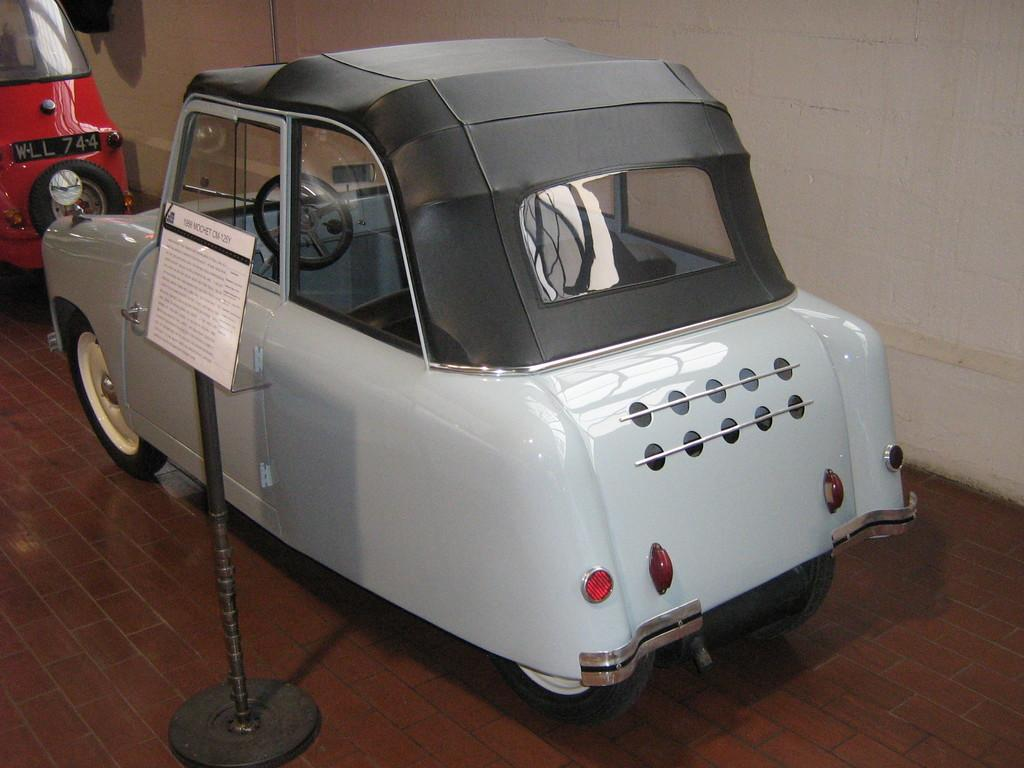What types of objects are present in the image? There are vehicles, a text board with a stand, a wall, and a floor in the image. Can you describe the vehicles in the image? The facts provided do not specify the type of vehicles in the image. What is the text board with a stand used for? The purpose of the text board with a stand is not mentioned in the facts. What is the wall made of? The facts provided do not specify the material of the wall. Where is the hydrant located in the image? There is no hydrant present in the image. What type of plate is being used by the person in the image? There is no person or plate present in the image. 